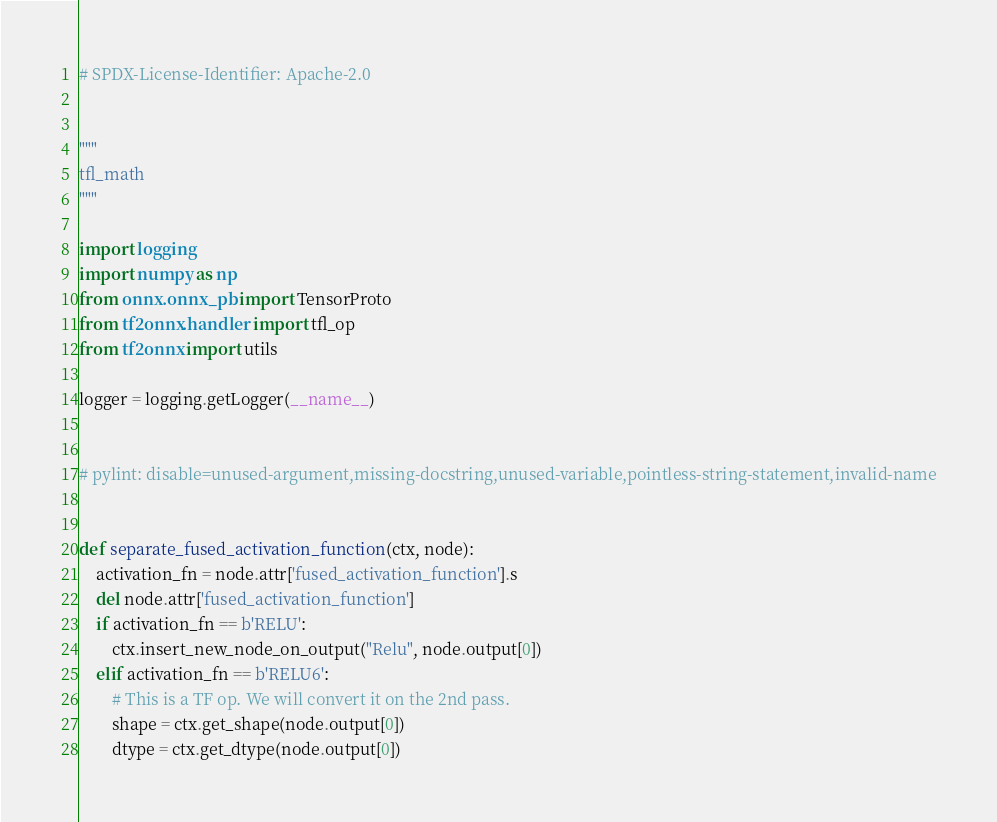Convert code to text. <code><loc_0><loc_0><loc_500><loc_500><_Python_># SPDX-License-Identifier: Apache-2.0


"""
tfl_math
"""

import logging
import numpy as np
from onnx.onnx_pb import TensorProto
from tf2onnx.handler import tfl_op
from tf2onnx import utils

logger = logging.getLogger(__name__)


# pylint: disable=unused-argument,missing-docstring,unused-variable,pointless-string-statement,invalid-name


def separate_fused_activation_function(ctx, node):
    activation_fn = node.attr['fused_activation_function'].s
    del node.attr['fused_activation_function']
    if activation_fn == b'RELU':
        ctx.insert_new_node_on_output("Relu", node.output[0])
    elif activation_fn == b'RELU6':
        # This is a TF op. We will convert it on the 2nd pass.
        shape = ctx.get_shape(node.output[0])
        dtype = ctx.get_dtype(node.output[0])</code> 